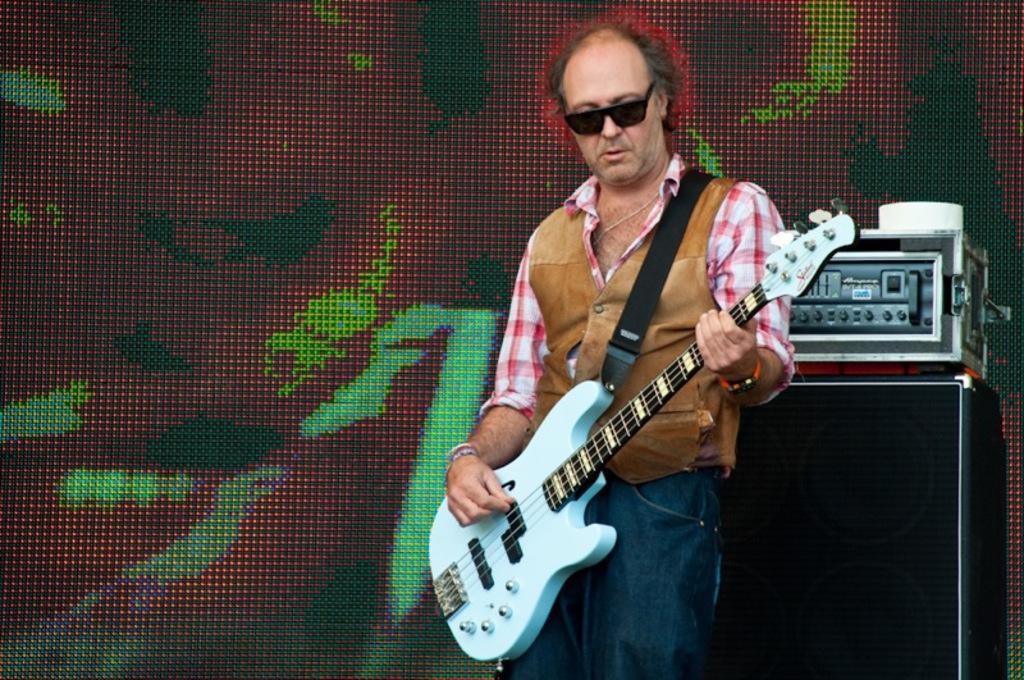Could you give a brief overview of what you see in this image? On the background we can see a device on a black box. We can see one man , wearing goggles , standing and playing guitar. 